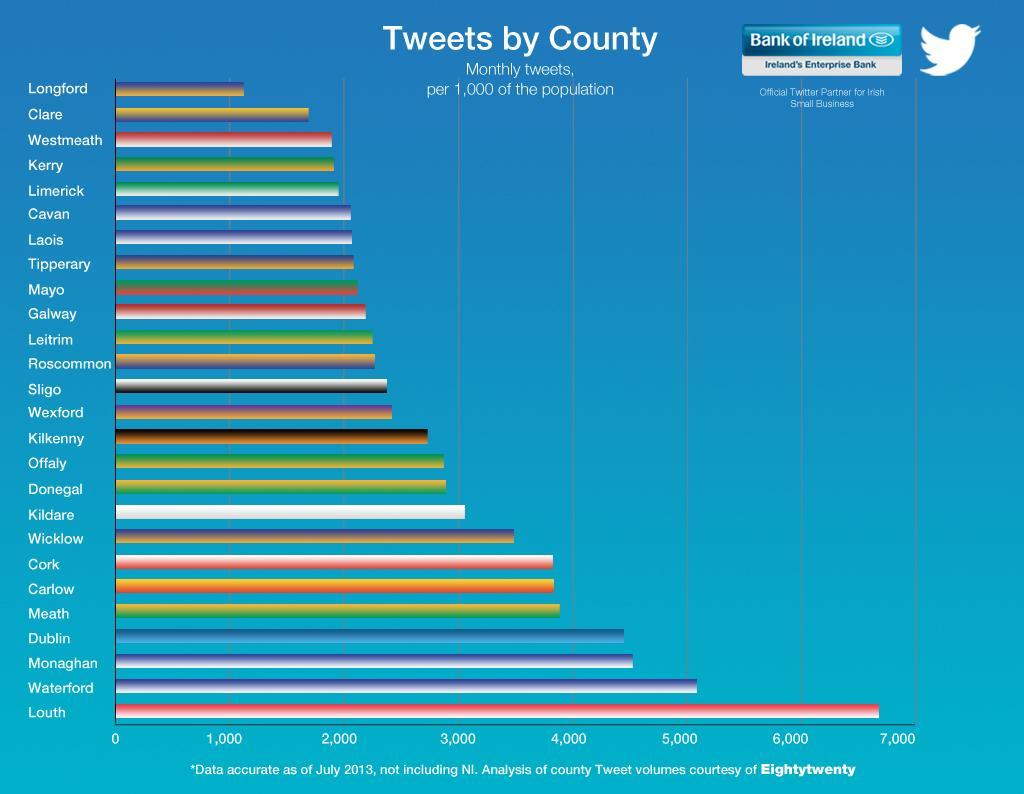Which counties fall just below the county Meath in number of tweets?
Answer the question with a short phrase. Cork,Carlow Which county has second highest number of tweets? Waterford 